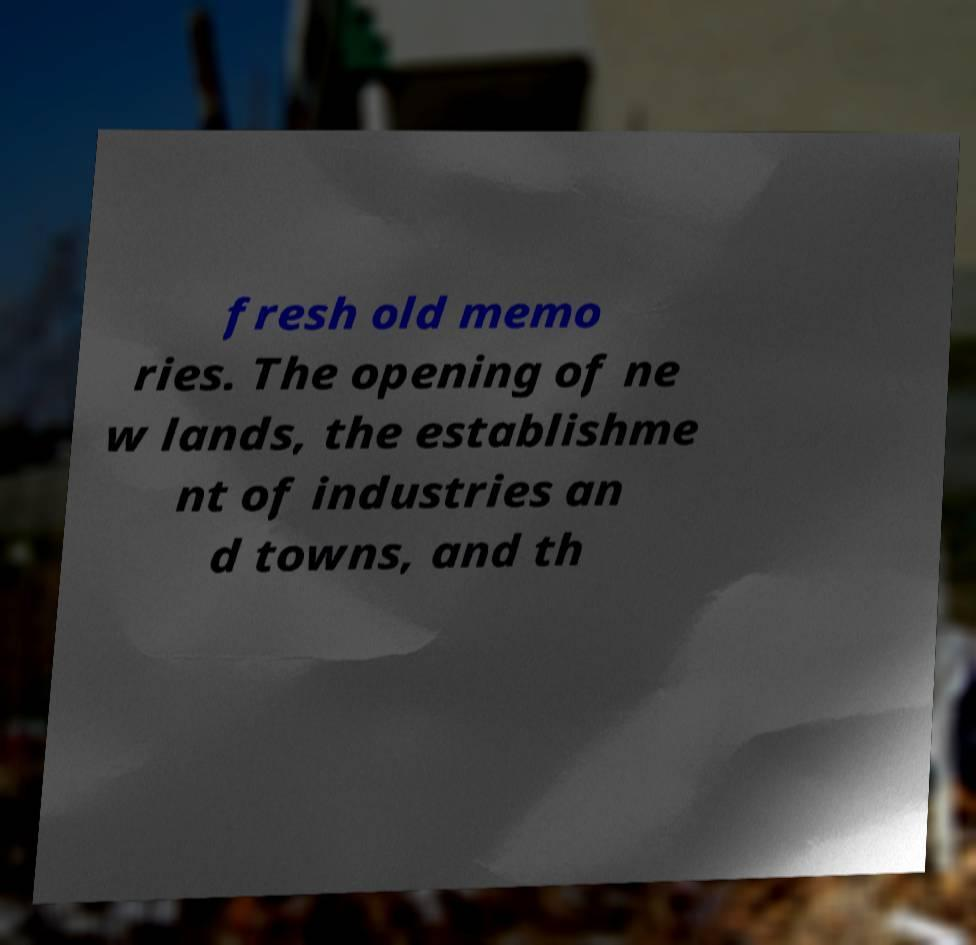Could you assist in decoding the text presented in this image and type it out clearly? fresh old memo ries. The opening of ne w lands, the establishme nt of industries an d towns, and th 